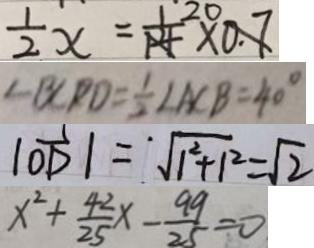Convert formula to latex. <formula><loc_0><loc_0><loc_500><loc_500>\frac { 1 } { 2 } x = \frac { 1 } { 1 4 } \times 0 . 7 
 \angle B C P D = \frac { 1 } { 2 } \angle A C B = 4 0 ^ { \circ } 
 \vert \overrightarrow { O D } \vert = ^ { \cdot } \sqrt { 1 ^ { 2 } + 1 ^ { 2 } } = \sqrt { 2 } 
 x ^ { 2 } + \frac { 4 2 } { 2 5 } x - \frac { 9 9 } { 2 5 } = 0</formula> 